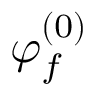<formula> <loc_0><loc_0><loc_500><loc_500>\varphi _ { f } ^ { ( 0 ) }</formula> 